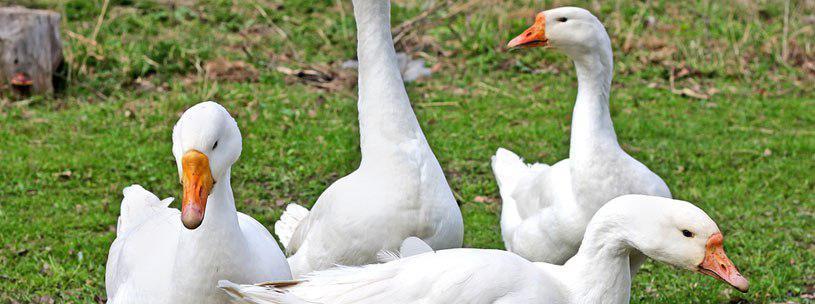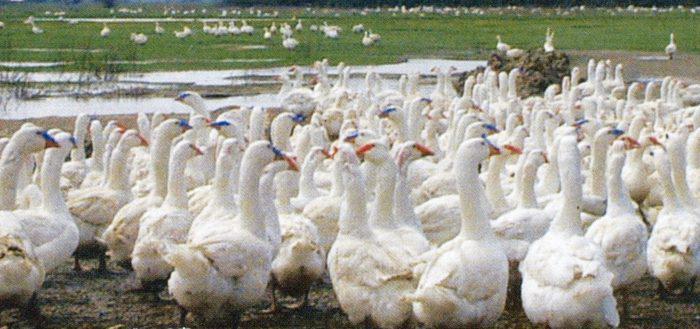The first image is the image on the left, the second image is the image on the right. For the images displayed, is the sentence "There is exactly one animal in the image on the left." factually correct? Answer yes or no. No. The first image is the image on the left, the second image is the image on the right. Analyze the images presented: Is the assertion "No image contains fewer than four white fowl." valid? Answer yes or no. Yes. 